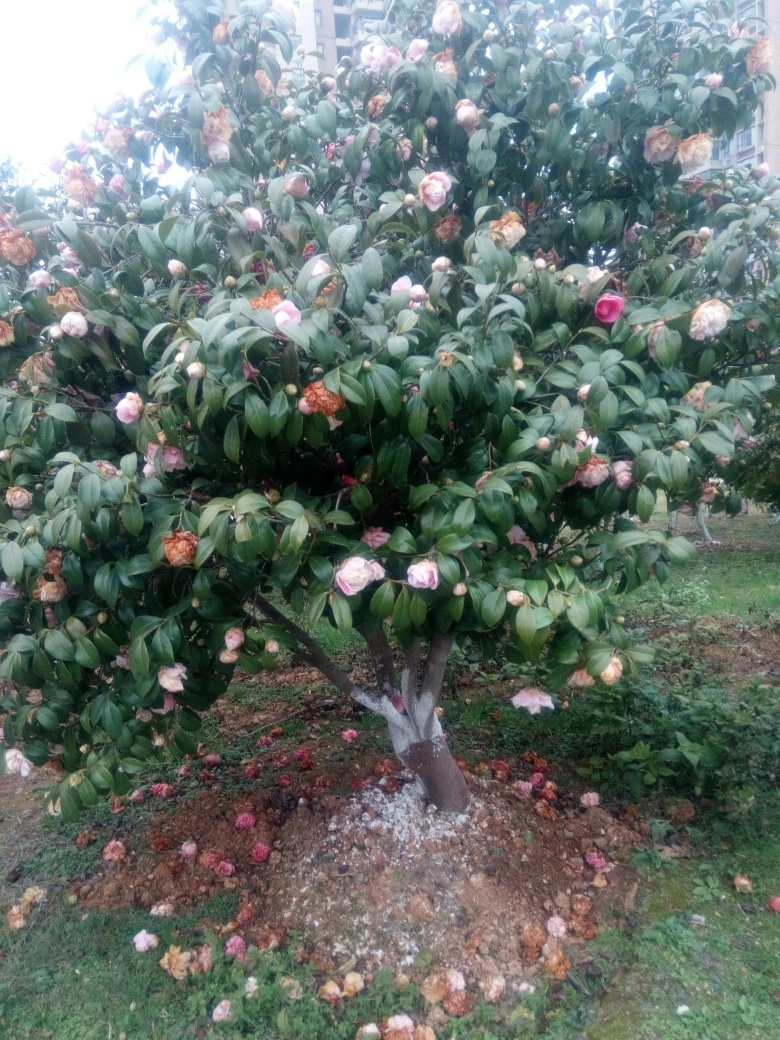Is there anything in the image that suggests the time of year or season? Camellia trees typically bloom from late winter through spring. The presence of both blooming flowers and fallen petals suggests it could be mid to late spring, as some flowers have already completed their life cycle, which aligns with the natural blooming period of camellias. 